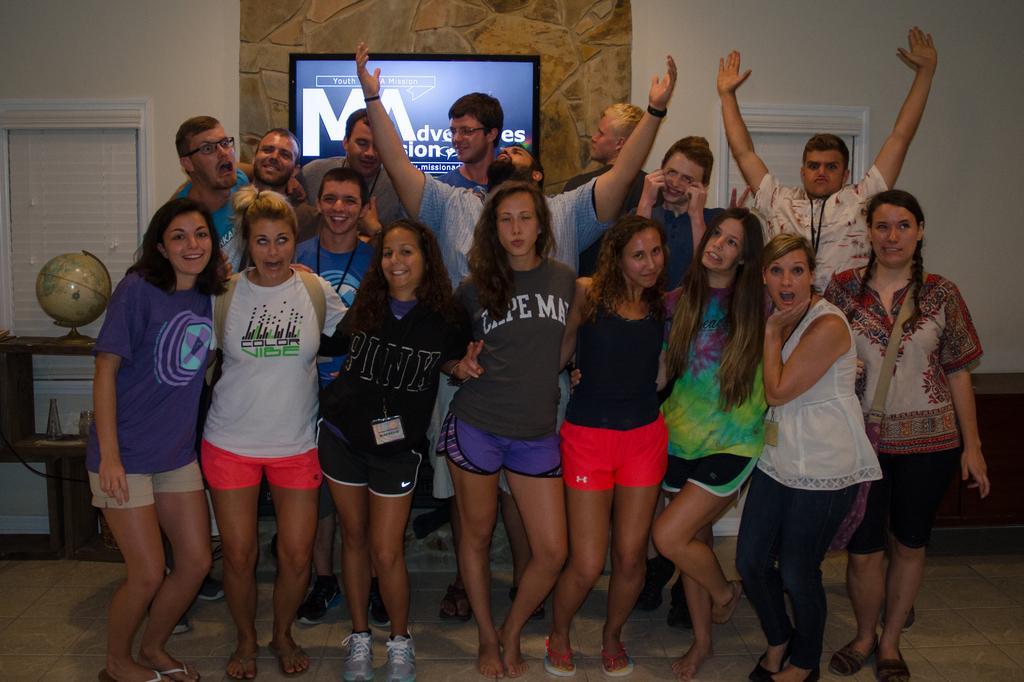Could you give a brief overview of what you see in this image? In this image we can see few persons are standing on the floor. In the background we can see a TV on the wall, windows, globe on a table and other objects. 